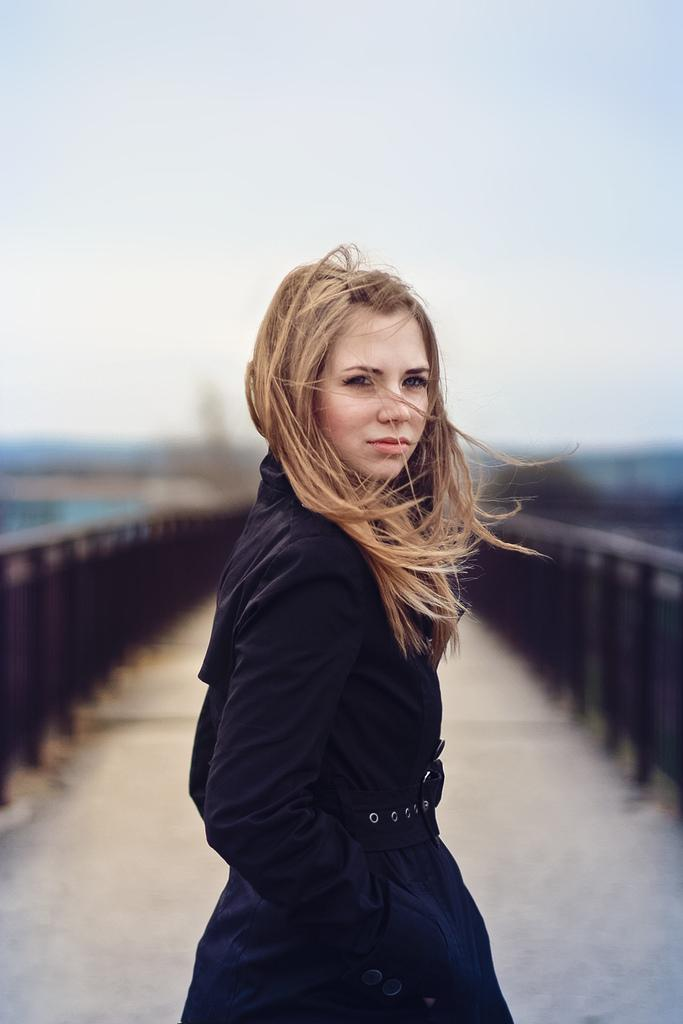What is the main subject of the image? The main subject of the image is the women standing in the center. Where are the women standing? The women are standing on the floor. What can be seen in the background of the image? There is a bridge and the sky visible in the background. Can you tell me how many boats are visible in the image? There are no boats present in the image; it features women standing on the floor with a bridge and the sky visible in the background. 